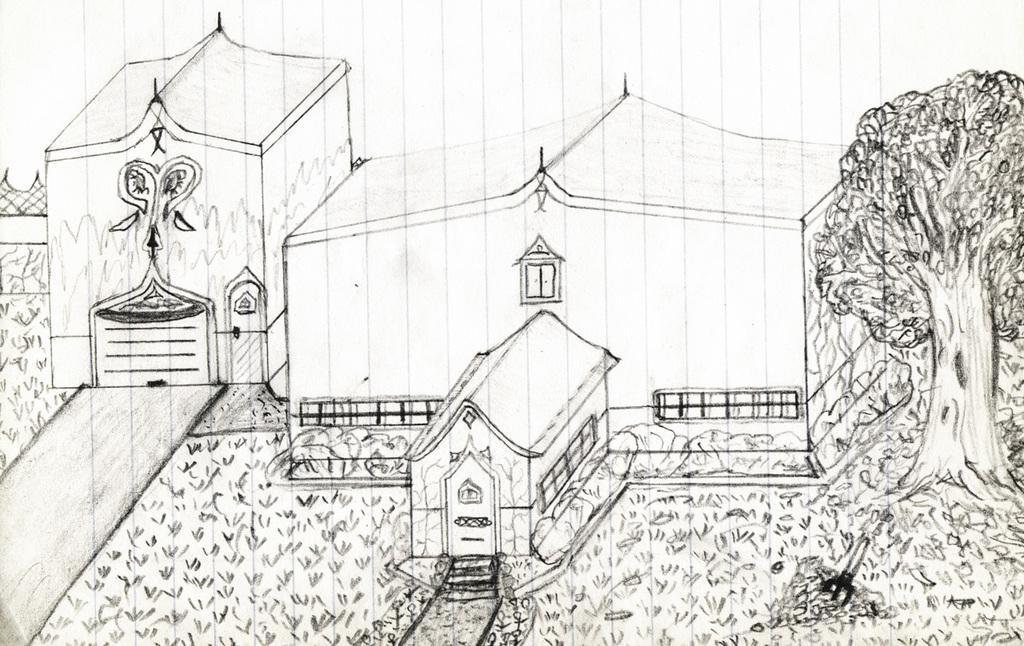Could you give a brief overview of what you see in this image? In this picture we see a drawing of a house with trees and grass on the ground. 